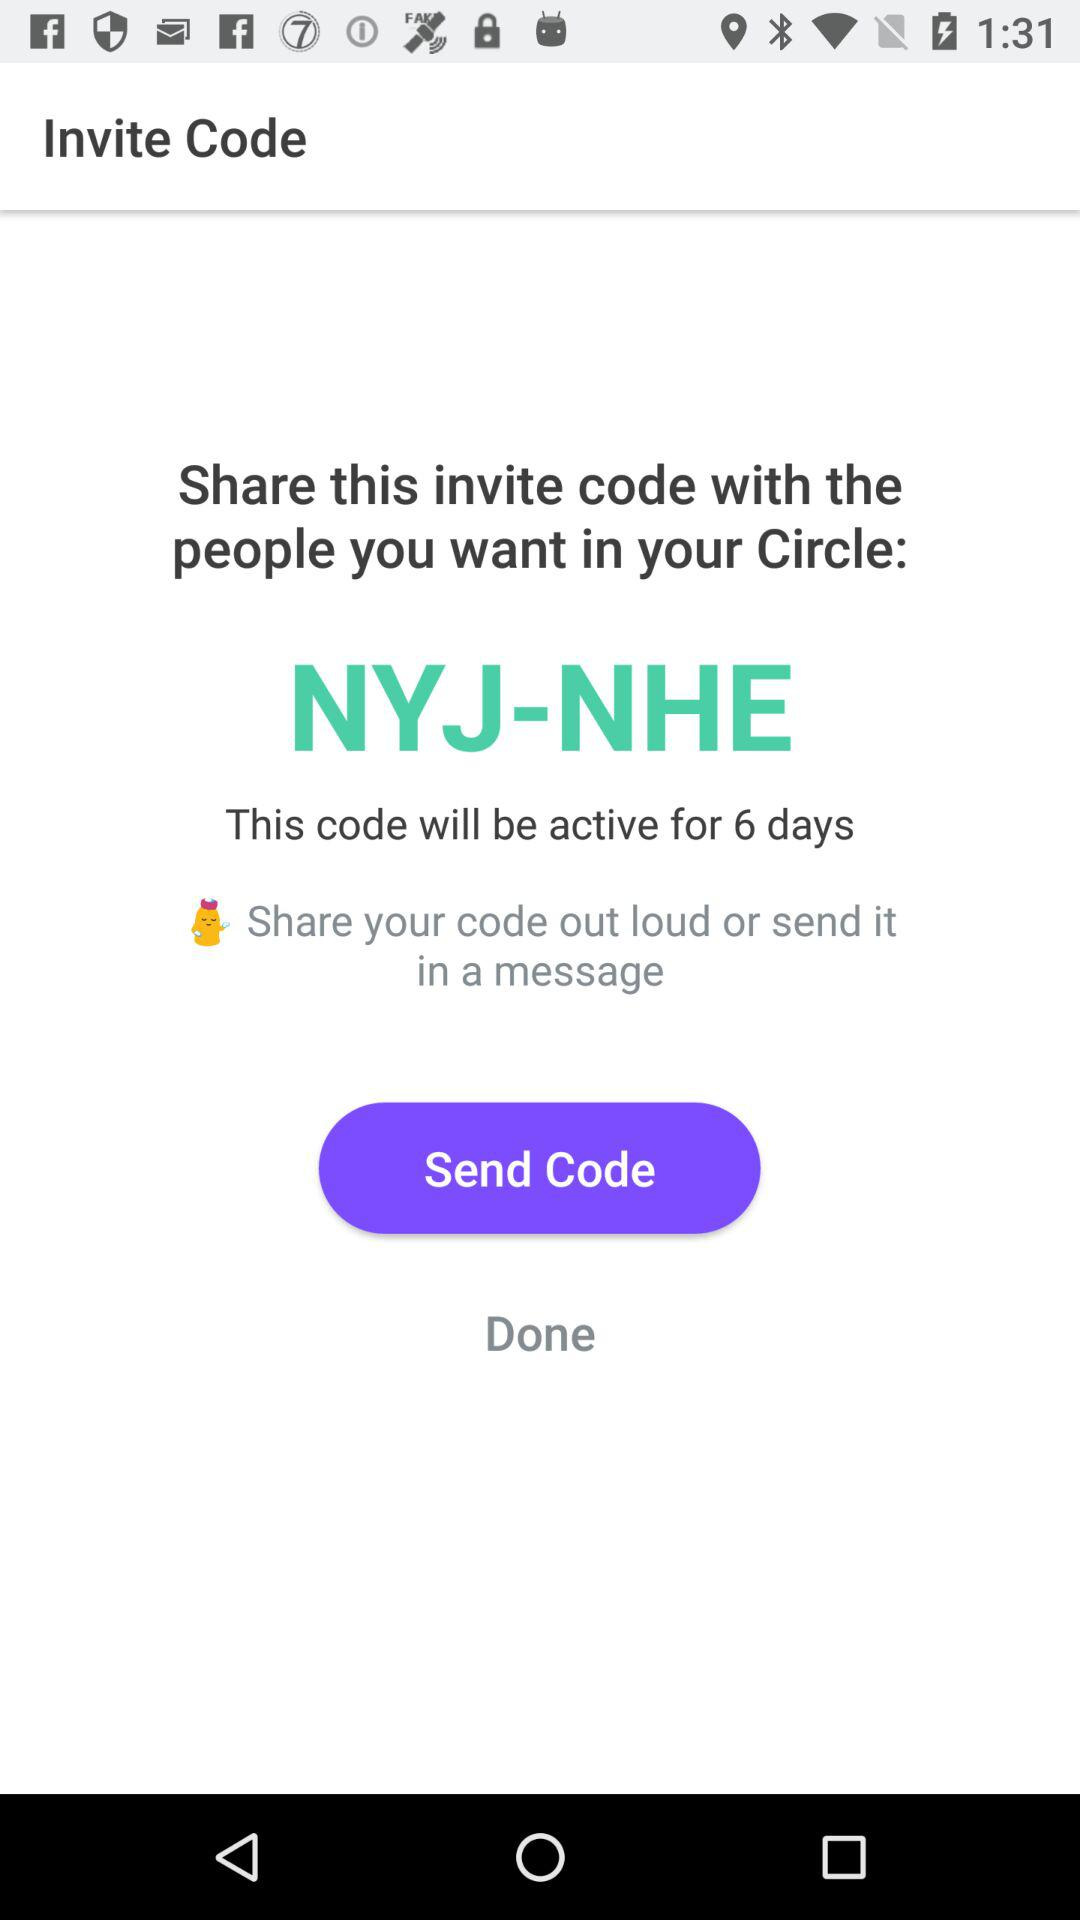For how many days can this code be active? This code can be active for 6 days. 